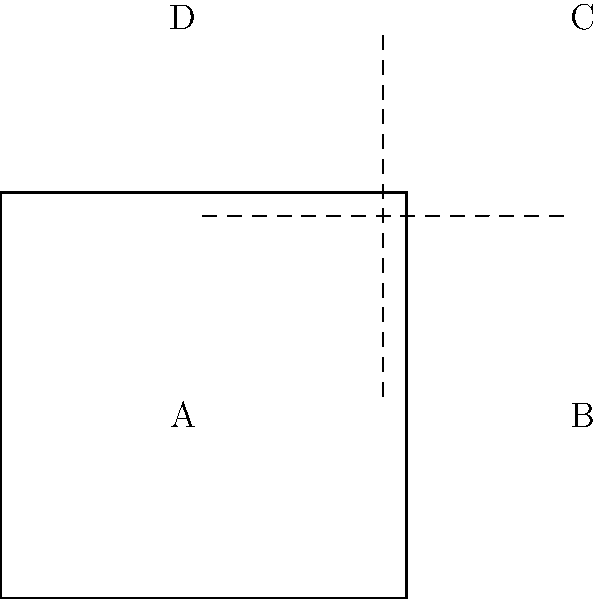A square campaign flyer for a Democratic judicial candidate is to be folded twice along the dashed lines shown in the diagram. If corner A is folded to meet corner C, and then the resulting shape is folded again so that corner B meets corner D, what will be the final shape of the visible area of the flyer? To solve this problem, we need to mentally follow the folding process:

1. The first fold brings corner A to meet corner C:
   - This fold creates a triangle shape.
   - The visible area becomes a right-angled triangle with the hypotenuse being the diagonal of the original square.

2. The second fold brings corner B to meet corner D:
   - This fold essentially halves the triangle from the first fold.
   - The resulting shape will be a smaller right-angled triangle.

3. Analyzing the final shape:
   - The visible area is now a right-angled triangle.
   - Its base and height are each 1/4 of the original square's side length.
   - The hypotenuse of this triangle is 1/4 of the original square's diagonal.

Therefore, the final visible shape of the flyer will be a right-angled triangle with sides in the ratio of 1:1:$\sqrt{2}$, but at 1/4 the scale of the original square.
Answer: Right-angled triangle 